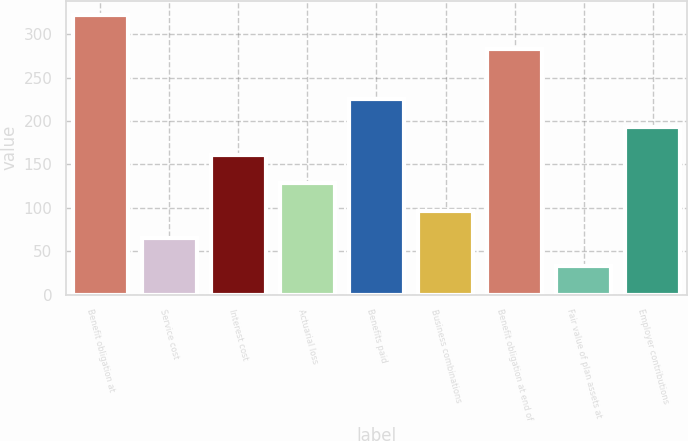Convert chart to OTSL. <chart><loc_0><loc_0><loc_500><loc_500><bar_chart><fcel>Benefit obligation at<fcel>Service cost<fcel>Interest cost<fcel>Actuarial loss<fcel>Benefits paid<fcel>Business combinations<fcel>Benefit obligation at end of<fcel>Fair value of plan assets at<fcel>Employer contributions<nl><fcel>322.6<fcel>64.6<fcel>161.35<fcel>129.1<fcel>225.85<fcel>96.85<fcel>282.7<fcel>32.35<fcel>193.6<nl></chart> 